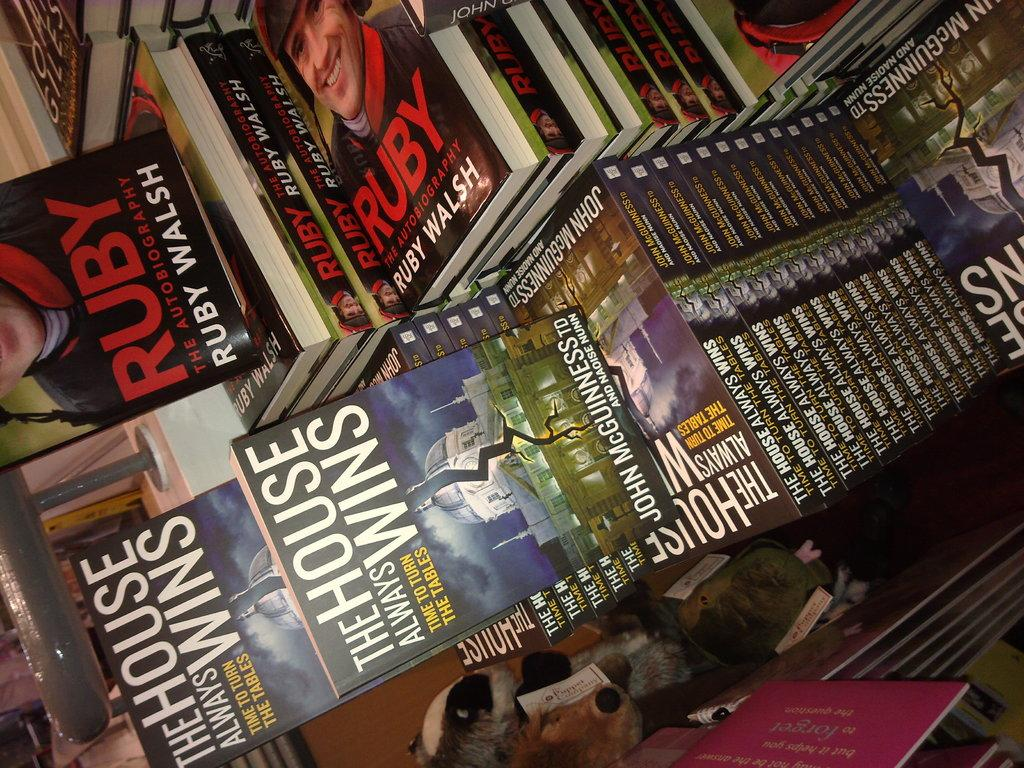<image>
Give a short and clear explanation of the subsequent image. Books stacked on top of each other many of them by Ruby Walsh. 